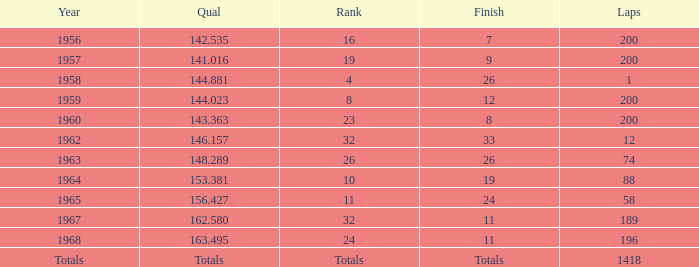What is the maximum number of laps with a final total of 8? 200.0. 